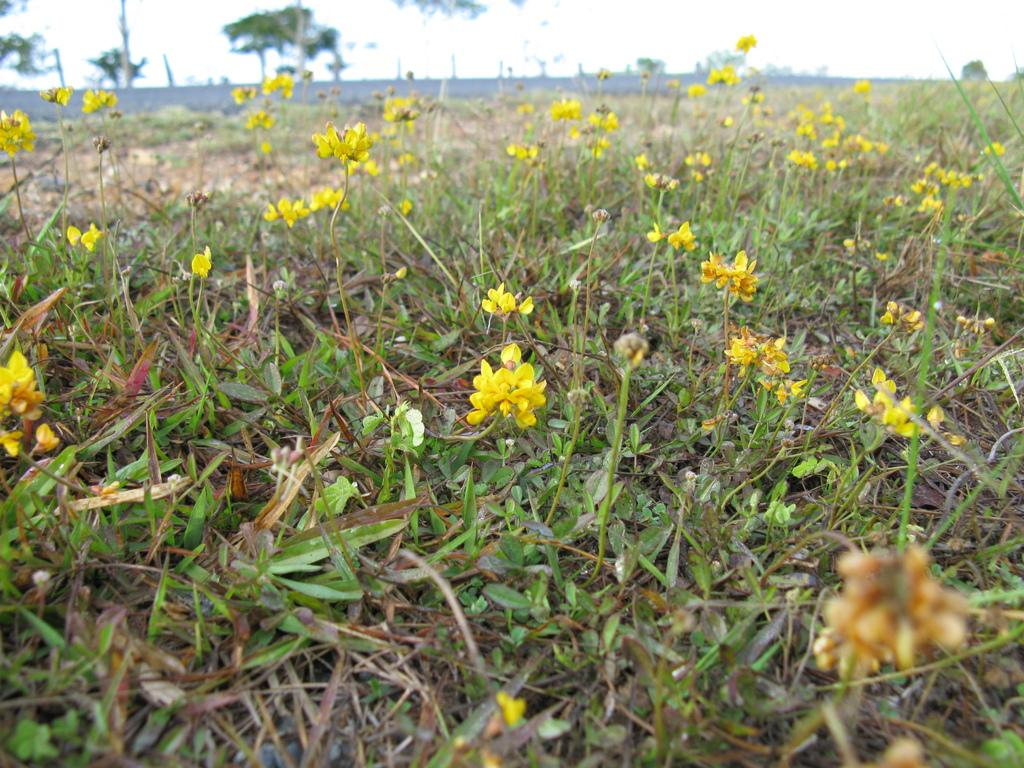What type of vegetation is on the ground in the image? There are plants on the ground in the image, and they have flowers. What else is on the ground in the image? There is grass on the ground in the image. What can be seen in the background of the image? There are trees and a wall in the background of the image. What is visible at the top of the image? The sky is visible at the top of the image. What type of linen is draped over the trees in the image? There is no linen draped over the trees in the image; the trees are standing on their own. Is there a house visible in the image? There is no house visible in the image; only plants, grass, trees, a wall, and the sky are present. 